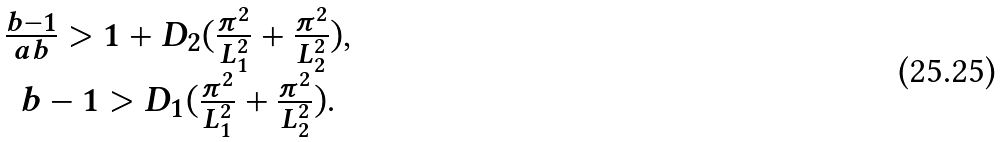<formula> <loc_0><loc_0><loc_500><loc_500>\begin{array} { c } \frac { b - 1 } { a b } > 1 + D _ { 2 } ( \frac { \pi ^ { 2 } } { L _ { 1 } ^ { 2 } } + \frac { \pi ^ { 2 } } { L _ { 2 } ^ { 2 } } ) , \\ b - 1 > D _ { 1 } ( \frac { \pi ^ { 2 } } { L _ { 1 } ^ { 2 } } + \frac { \pi ^ { 2 } } { L _ { 2 } ^ { 2 } } ) . \end{array}</formula> 